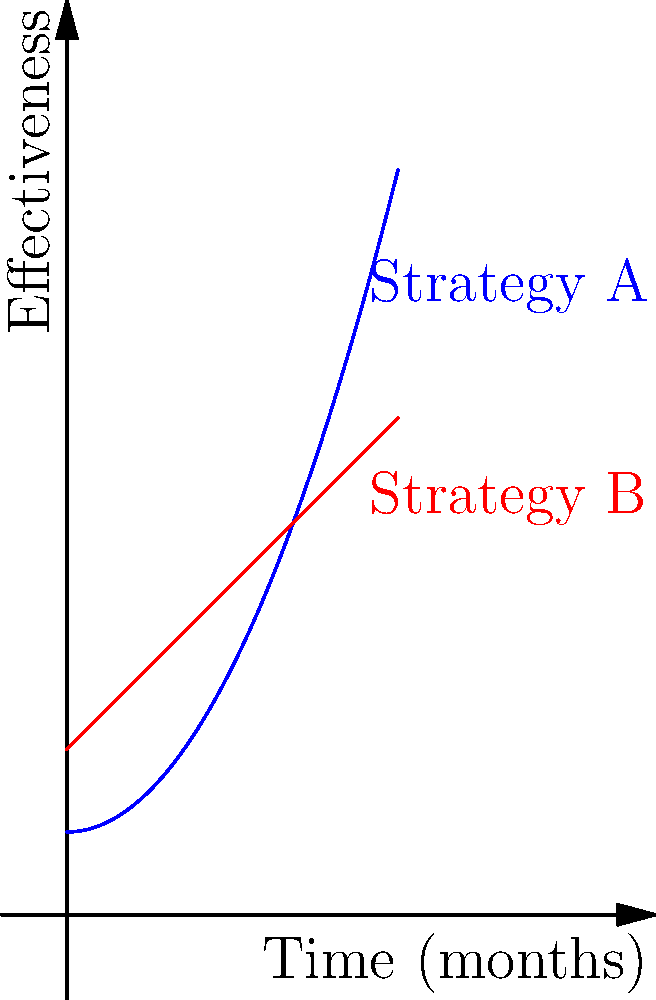Your marketing team has presented you with a graph showing the effectiveness of two marketing strategies over time. Strategy A is represented by the function $f(x) = 0.5x^2 + 1$, and Strategy B is represented by the function $g(x) = x + 2$, where $x$ is the time in months and $y$ is the effectiveness score. Calculate the difference in total effectiveness between Strategy A and Strategy B over the first 4 months by finding the area between the two curves. To find the area between the two curves, we need to:

1. Determine the limits of integration: $x = 0$ to $x = 4$

2. Set up the integral: 
   $$\int_0^4 [f(x) - g(x)] dx = \int_0^4 [(0.5x^2 + 1) - (x + 2)] dx$$

3. Simplify the integrand:
   $$\int_0^4 (0.5x^2 - x - 1) dx$$

4. Integrate:
   $$\left[ \frac{1}{6}x^3 - \frac{1}{2}x^2 - x \right]_0^4$$

5. Evaluate the definite integral:
   $$\left( \frac{1}{6}(4^3) - \frac{1}{2}(4^2) - 4 \right) - \left( \frac{1}{6}(0^3) - \frac{1}{2}(0^2) - 0 \right)$$
   $$(10.67 - 8 - 4) - (0 - 0 - 0) = -1.33$$

6. The negative result indicates that Strategy B was more effective overall.

7. Take the absolute value for the final answer: $|{-1.33}| = 1.33$
Answer: 1.33 effectiveness-months 